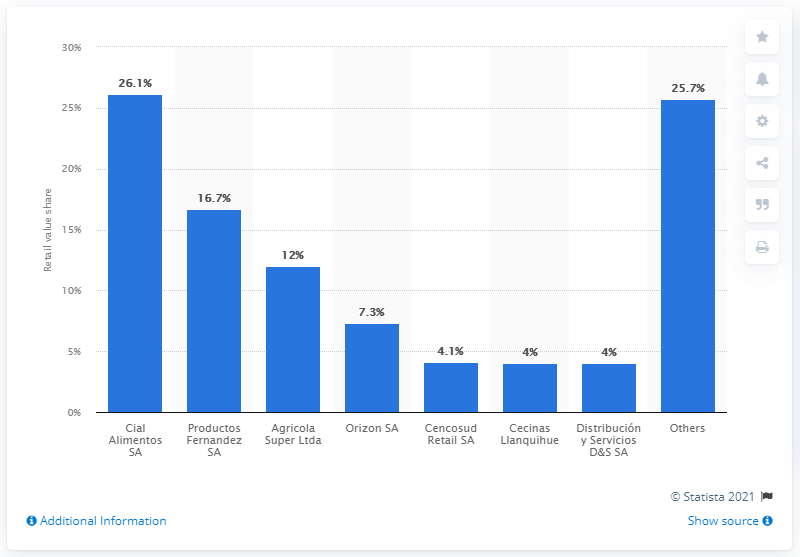Mention a couple of crucial points in this snapshot. According to a report, Cial Alimentos SA accounted for 26.1 percent of the processed meat and seafood retail value in Chile in 2017. This made the company a significant player in the Chilean market for processed meats and seafood. In 2017, Cial Alimentos SA accounted for 26.1% of Chile's retail value. 